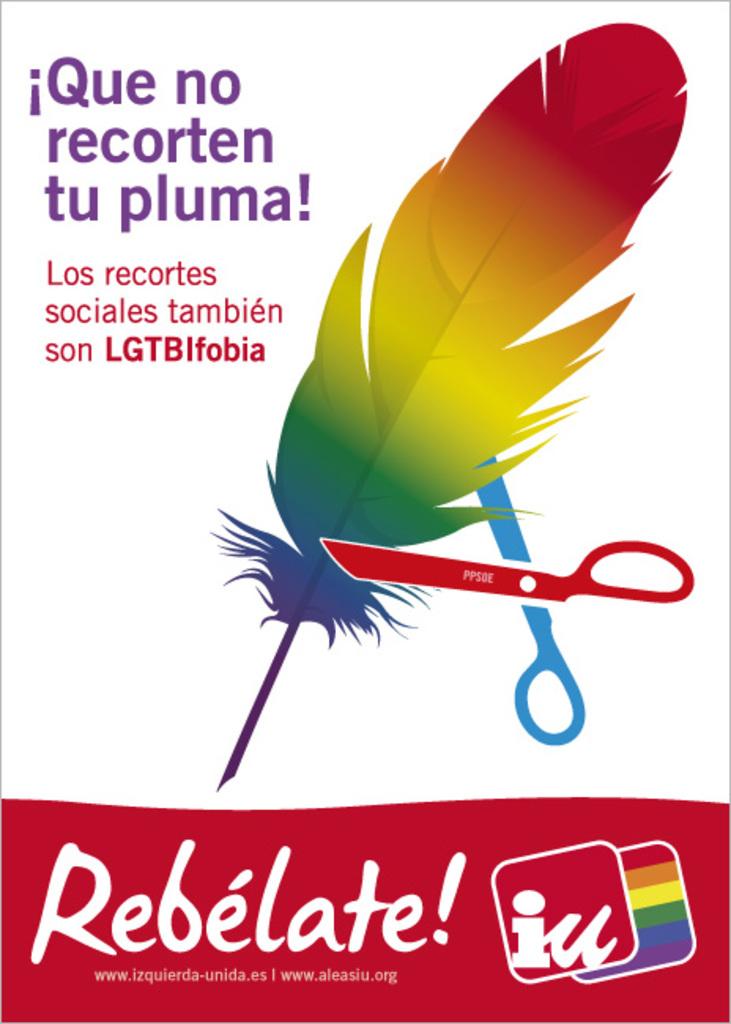What color is the text at the top?
Offer a terse response. Purple. What color is the text at the bottom?
Offer a very short reply. Answering does not require reading text in the image. 